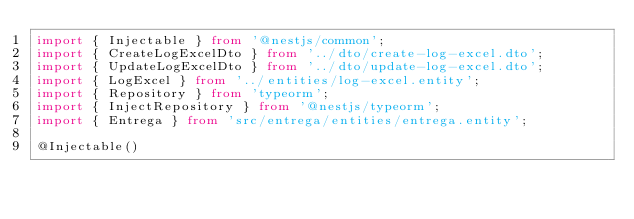Convert code to text. <code><loc_0><loc_0><loc_500><loc_500><_TypeScript_>import { Injectable } from '@nestjs/common';
import { CreateLogExcelDto } from '../dto/create-log-excel.dto';
import { UpdateLogExcelDto } from '../dto/update-log-excel.dto';
import { LogExcel } from '../entities/log-excel.entity';
import { Repository } from 'typeorm';
import { InjectRepository } from '@nestjs/typeorm';
import { Entrega } from 'src/entrega/entities/entrega.entity';

@Injectable()</code> 